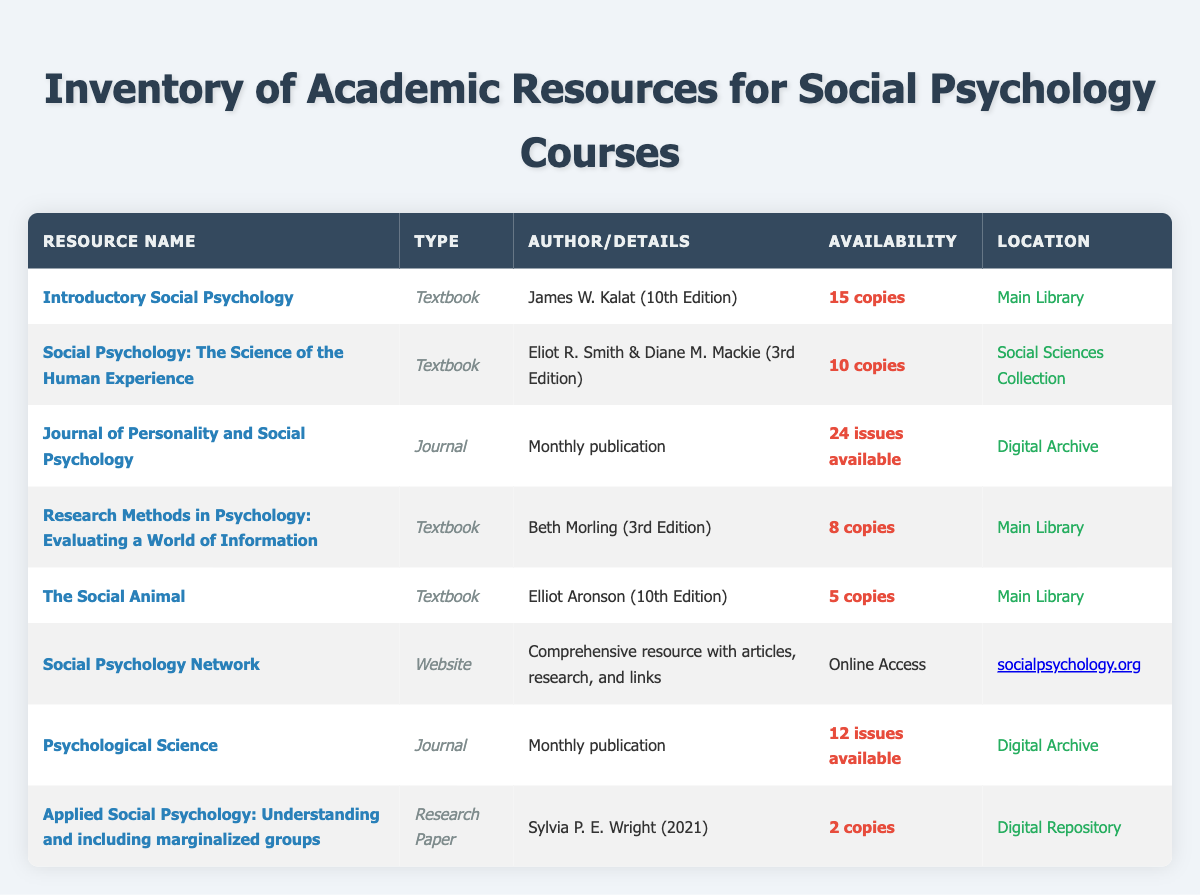What is the total number of available copies of textbooks in the inventory? The available copies for each textbook are: Introductory Social Psychology (15), Social Psychology: The Science of the Human Experience (10), Research Methods in Psychology (8), and The Social Animal (5). Adding these gives: 15 + 10 + 8 + 5 = 38.
Answer: 38 How many journals are available in the inventory? The inventory lists two journals: Journal of Personality and Social Psychology and Psychological Science. Therefore, the total count of journals is 2.
Answer: 2 Is there a research paper available that discusses marginalized groups? Yes, there is a research paper titled "Applied Social Psychology: Understanding and including marginalized groups" authored by Sylvia P. E. Wright.
Answer: Yes What is the average number of available copies for textbooks listed? The available copies for textbooks are 15, 10, 8, and 5. To find the average, first sum these values: 15 + 10 + 8 + 5 = 38. There are 4 textbooks, so the average is 38 / 4 = 9.5.
Answer: 9.5 Which resource has the least number of available copies, and how many copies are there? The resources with available copies are: Introductory Social Psychology (15), Social Psychology: The Science of the Human Experience (10), Research Methods in Psychology (8), The Social Animal (5), and the research paper (2). The resource with the least is the research paper with only 2 copies.
Answer: Applied Social Psychology: Understanding and including marginalized groups, 2 copies How many copies of "Research Methods in Psychology" are available for borrowing? The available copies listed for "Research Methods in Psychology: Evaluating a World of Information" are 8.
Answer: 8 Which location contains the most academic resources? By observing the locations, the Main Library contains three textbooks (Introductory Social Psychology, Research Methods in Psychology, and The Social Animal), while the Social Sciences Collection has one textbook, and the Digital Archive contains two journals. Thus, the Main Library has the most academic resources.
Answer: Main Library Is the "Social Psychology Network" a physical book or an online resource? The "Social Psychology Network" is classified as a website with online access, not a physical book.
Answer: Online resource 